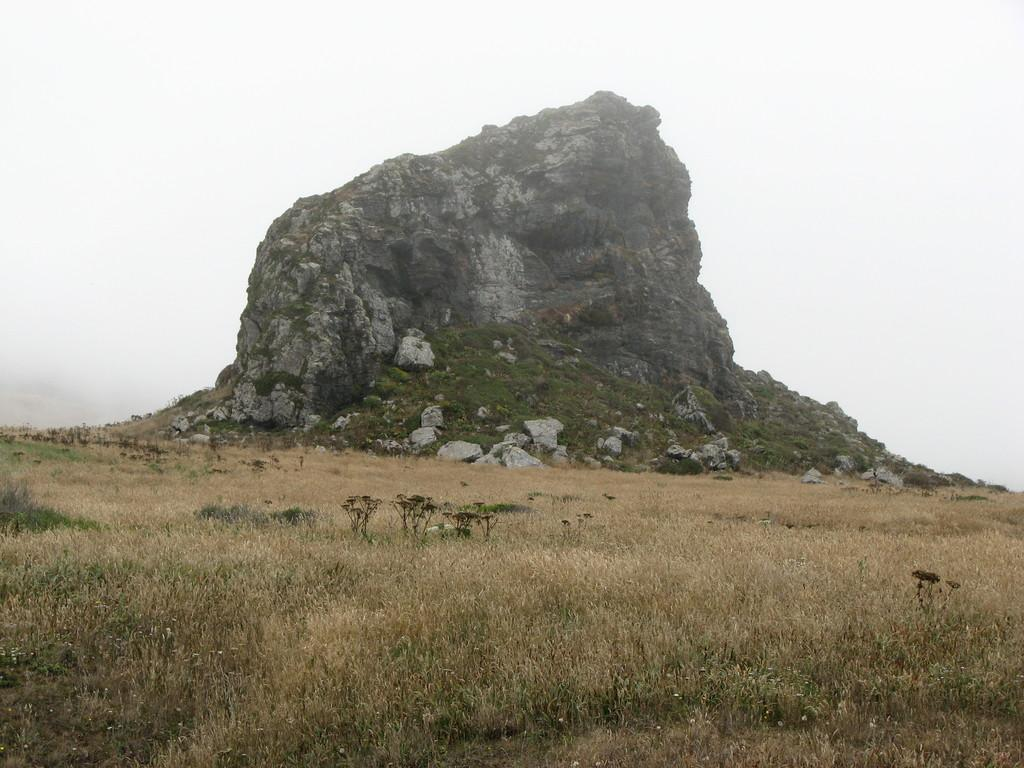What type of vegetation is present in the image? There is grass and plants in the image. What geographical feature can be seen in the image? There is a hill in the image. What part of the natural environment is visible in the background of the image? The sky is visible in the background of the image. What type of eggnog is being served on the hill in the image? There is no eggnog present in the image; it features grass, plants, and a hill. 